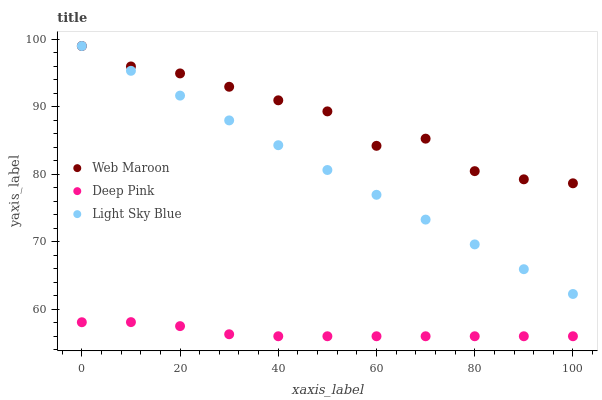Does Deep Pink have the minimum area under the curve?
Answer yes or no. Yes. Does Web Maroon have the maximum area under the curve?
Answer yes or no. Yes. Does Light Sky Blue have the minimum area under the curve?
Answer yes or no. No. Does Light Sky Blue have the maximum area under the curve?
Answer yes or no. No. Is Light Sky Blue the smoothest?
Answer yes or no. Yes. Is Web Maroon the roughest?
Answer yes or no. Yes. Is Web Maroon the smoothest?
Answer yes or no. No. Is Light Sky Blue the roughest?
Answer yes or no. No. Does Deep Pink have the lowest value?
Answer yes or no. Yes. Does Light Sky Blue have the lowest value?
Answer yes or no. No. Does Light Sky Blue have the highest value?
Answer yes or no. Yes. Is Deep Pink less than Light Sky Blue?
Answer yes or no. Yes. Is Light Sky Blue greater than Deep Pink?
Answer yes or no. Yes. Does Web Maroon intersect Light Sky Blue?
Answer yes or no. Yes. Is Web Maroon less than Light Sky Blue?
Answer yes or no. No. Is Web Maroon greater than Light Sky Blue?
Answer yes or no. No. Does Deep Pink intersect Light Sky Blue?
Answer yes or no. No. 